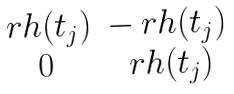<formula> <loc_0><loc_0><loc_500><loc_500>\begin{matrix} \ r h ( t _ { j } ) & - \ r h ( t _ { j } ) \\ 0 & \ r h ( t _ { j } ) \end{matrix}</formula> 